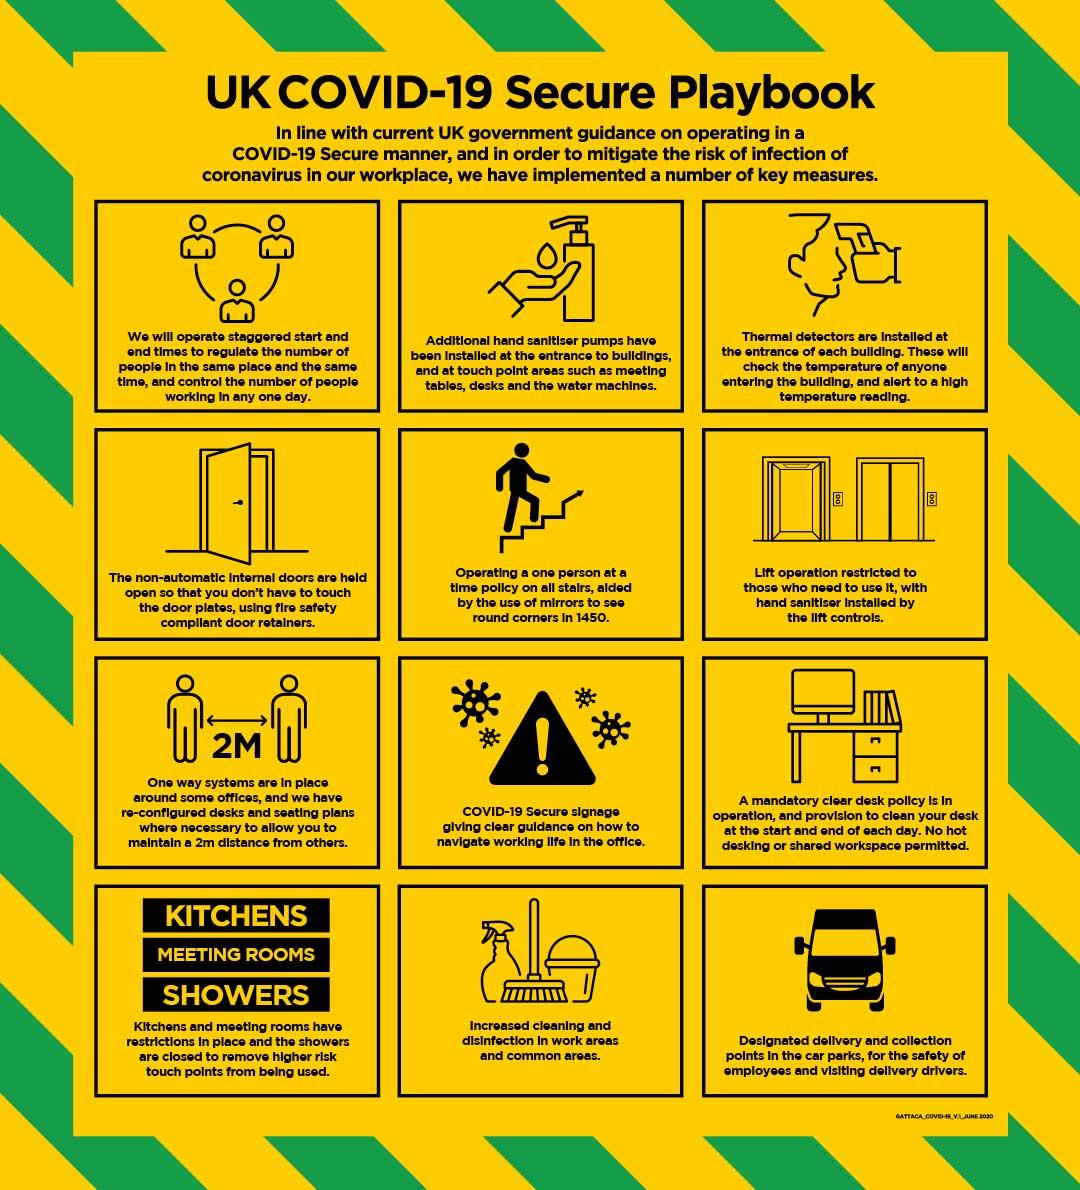Highlight a few significant elements in this photo. Mirrors were used in staircases during the year 1450 to enable individuals to see around corners. There are 12 key measures listed in the infographic. The equipment used to check the temperature of people is known as a Thermal Detector. 